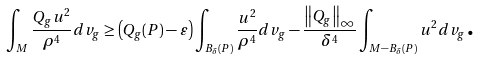Convert formula to latex. <formula><loc_0><loc_0><loc_500><loc_500>\int _ { M } \frac { Q _ { g } u ^ { 2 } } { \rho ^ { 4 } } d v _ { g } \geq \left ( Q _ { g } ( P ) - \varepsilon \right ) \int _ { B _ { \delta } ( P ) } \frac { u ^ { 2 } } { \rho ^ { 4 } } d v _ { g } - \frac { \left \| Q _ { g } \right \| _ { \infty } } { \delta ^ { 4 } } \int _ { M - B _ { \delta } \left ( P \right ) } u ^ { 2 } d v _ { g } \text {.}</formula> 